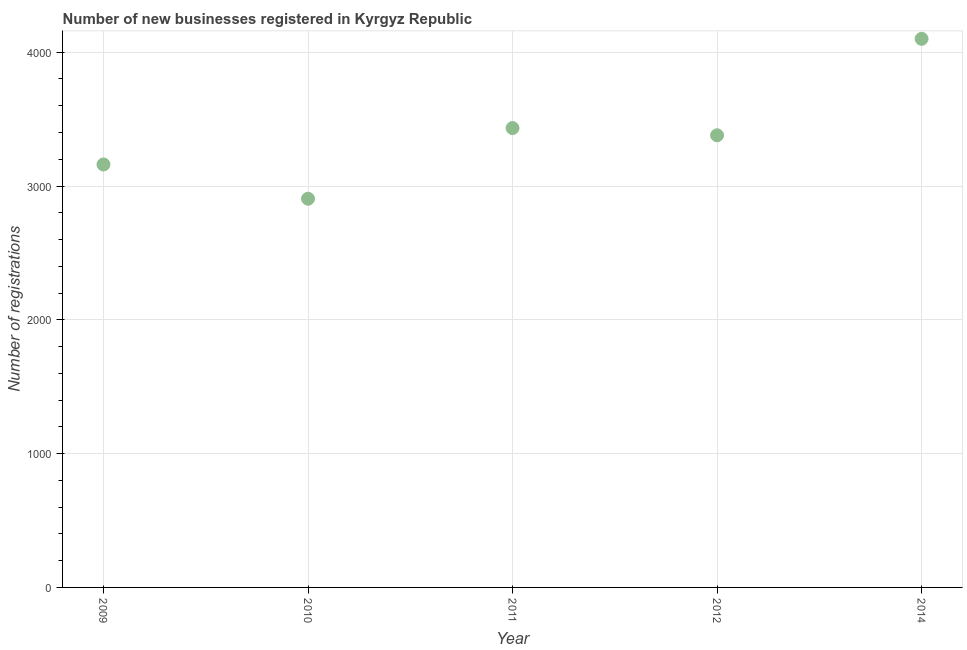What is the number of new business registrations in 2014?
Provide a short and direct response. 4100. Across all years, what is the maximum number of new business registrations?
Offer a very short reply. 4100. Across all years, what is the minimum number of new business registrations?
Ensure brevity in your answer.  2905. In which year was the number of new business registrations maximum?
Provide a short and direct response. 2014. In which year was the number of new business registrations minimum?
Offer a very short reply. 2010. What is the sum of the number of new business registrations?
Make the answer very short. 1.70e+04. What is the difference between the number of new business registrations in 2009 and 2010?
Provide a succinct answer. 256. What is the average number of new business registrations per year?
Make the answer very short. 3395.6. What is the median number of new business registrations?
Provide a succinct answer. 3379. Do a majority of the years between 2009 and 2014 (inclusive) have number of new business registrations greater than 1200 ?
Provide a succinct answer. Yes. What is the ratio of the number of new business registrations in 2011 to that in 2014?
Provide a succinct answer. 0.84. What is the difference between the highest and the second highest number of new business registrations?
Your answer should be compact. 667. What is the difference between the highest and the lowest number of new business registrations?
Your response must be concise. 1195. In how many years, is the number of new business registrations greater than the average number of new business registrations taken over all years?
Offer a very short reply. 2. Does the number of new business registrations monotonically increase over the years?
Ensure brevity in your answer.  No. What is the difference between two consecutive major ticks on the Y-axis?
Provide a succinct answer. 1000. Are the values on the major ticks of Y-axis written in scientific E-notation?
Keep it short and to the point. No. Does the graph contain any zero values?
Provide a succinct answer. No. Does the graph contain grids?
Offer a terse response. Yes. What is the title of the graph?
Provide a short and direct response. Number of new businesses registered in Kyrgyz Republic. What is the label or title of the X-axis?
Provide a short and direct response. Year. What is the label or title of the Y-axis?
Keep it short and to the point. Number of registrations. What is the Number of registrations in 2009?
Give a very brief answer. 3161. What is the Number of registrations in 2010?
Give a very brief answer. 2905. What is the Number of registrations in 2011?
Provide a short and direct response. 3433. What is the Number of registrations in 2012?
Your response must be concise. 3379. What is the Number of registrations in 2014?
Offer a very short reply. 4100. What is the difference between the Number of registrations in 2009 and 2010?
Keep it short and to the point. 256. What is the difference between the Number of registrations in 2009 and 2011?
Keep it short and to the point. -272. What is the difference between the Number of registrations in 2009 and 2012?
Your response must be concise. -218. What is the difference between the Number of registrations in 2009 and 2014?
Your answer should be very brief. -939. What is the difference between the Number of registrations in 2010 and 2011?
Your answer should be very brief. -528. What is the difference between the Number of registrations in 2010 and 2012?
Provide a short and direct response. -474. What is the difference between the Number of registrations in 2010 and 2014?
Offer a terse response. -1195. What is the difference between the Number of registrations in 2011 and 2014?
Ensure brevity in your answer.  -667. What is the difference between the Number of registrations in 2012 and 2014?
Your answer should be compact. -721. What is the ratio of the Number of registrations in 2009 to that in 2010?
Ensure brevity in your answer.  1.09. What is the ratio of the Number of registrations in 2009 to that in 2011?
Your answer should be very brief. 0.92. What is the ratio of the Number of registrations in 2009 to that in 2012?
Your answer should be very brief. 0.94. What is the ratio of the Number of registrations in 2009 to that in 2014?
Provide a succinct answer. 0.77. What is the ratio of the Number of registrations in 2010 to that in 2011?
Offer a terse response. 0.85. What is the ratio of the Number of registrations in 2010 to that in 2012?
Keep it short and to the point. 0.86. What is the ratio of the Number of registrations in 2010 to that in 2014?
Offer a terse response. 0.71. What is the ratio of the Number of registrations in 2011 to that in 2014?
Give a very brief answer. 0.84. What is the ratio of the Number of registrations in 2012 to that in 2014?
Give a very brief answer. 0.82. 